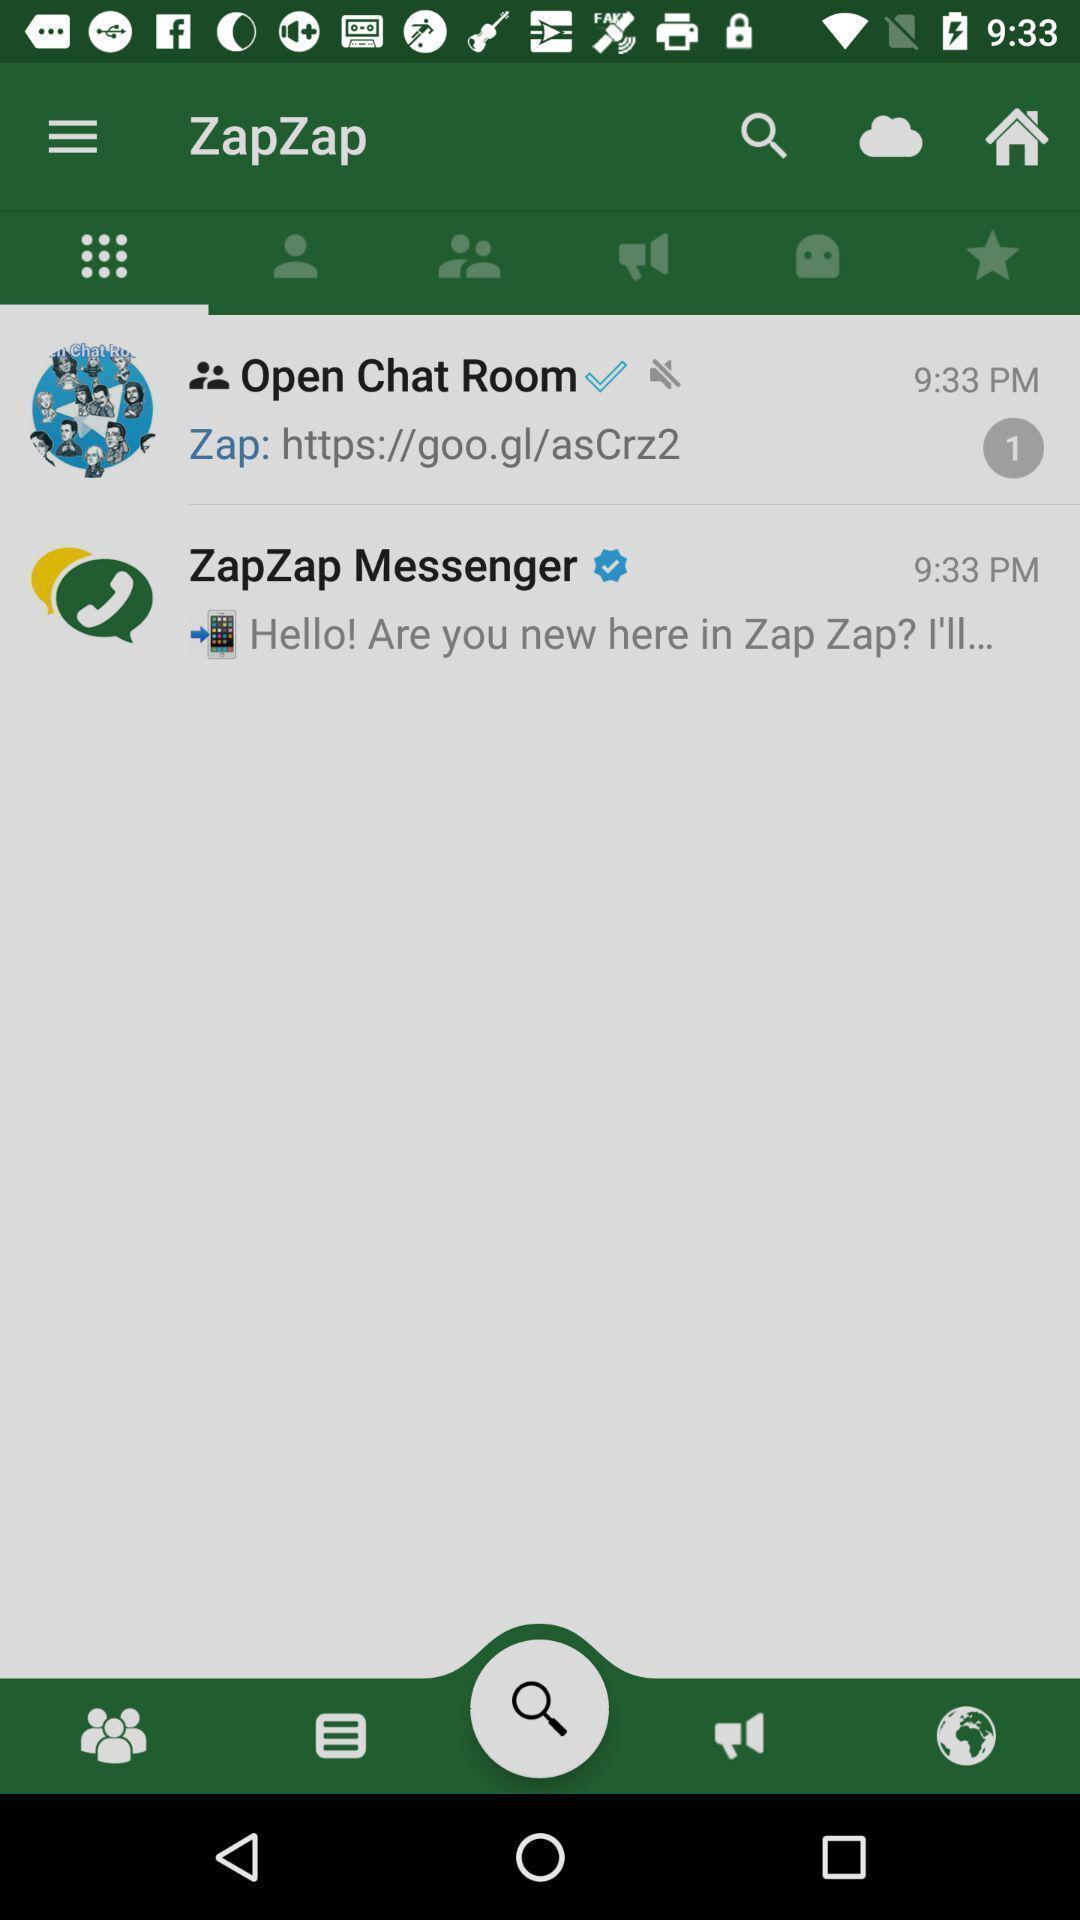Summarize the information in this screenshot. Screen showing home page with options. 